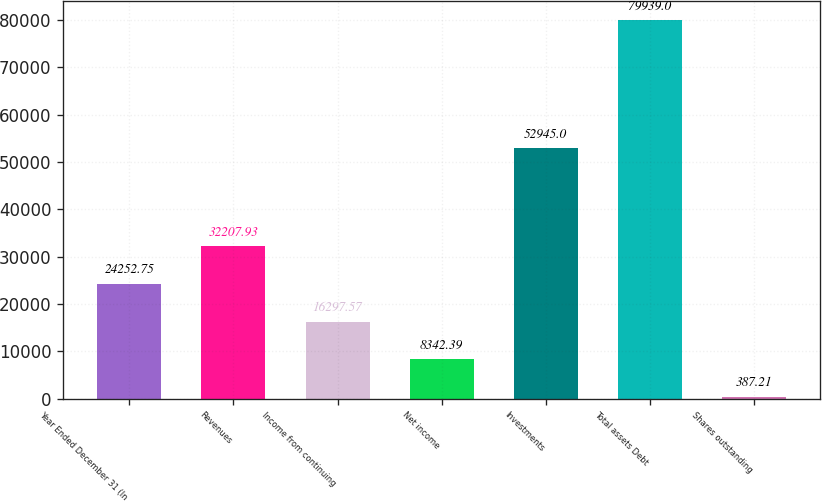Convert chart. <chart><loc_0><loc_0><loc_500><loc_500><bar_chart><fcel>Year Ended December 31 (In<fcel>Revenues<fcel>Income from continuing<fcel>Net income<fcel>Investments<fcel>Total assets Debt<fcel>Shares outstanding<nl><fcel>24252.8<fcel>32207.9<fcel>16297.6<fcel>8342.39<fcel>52945<fcel>79939<fcel>387.21<nl></chart> 